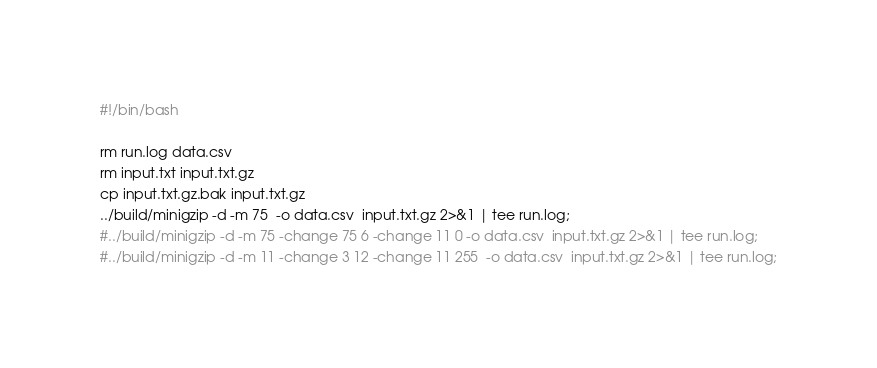Convert code to text. <code><loc_0><loc_0><loc_500><loc_500><_Bash_>#!/bin/bash

rm run.log data.csv
rm input.txt input.txt.gz
cp input.txt.gz.bak input.txt.gz
../build/minigzip -d -m 75  -o data.csv  input.txt.gz 2>&1 | tee run.log;
#../build/minigzip -d -m 75 -change 75 6 -change 11 0 -o data.csv  input.txt.gz 2>&1 | tee run.log;
#../build/minigzip -d -m 11 -change 3 12 -change 11 255  -o data.csv  input.txt.gz 2>&1 | tee run.log;

</code> 